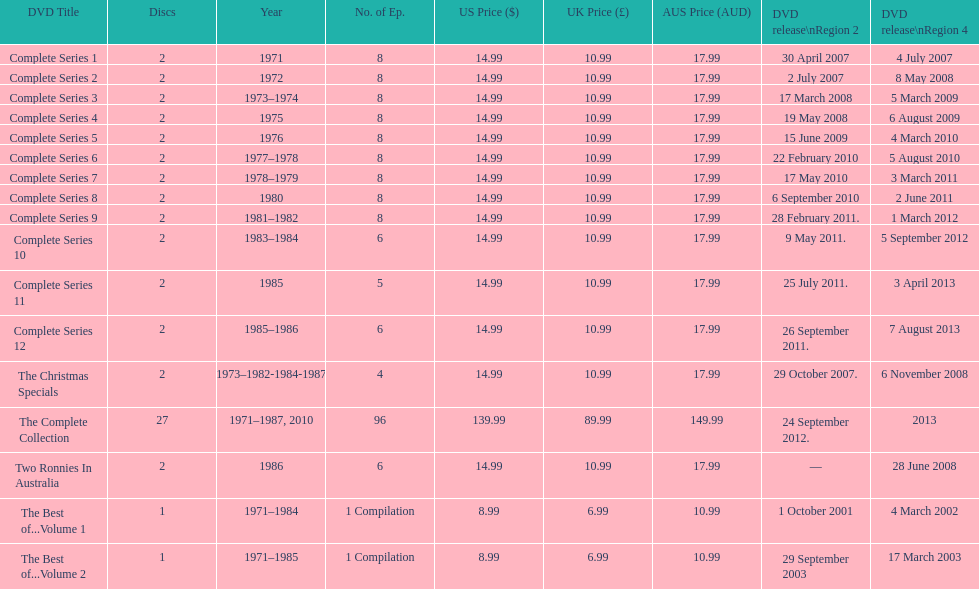What is the total of all dics listed in the table? 57. 